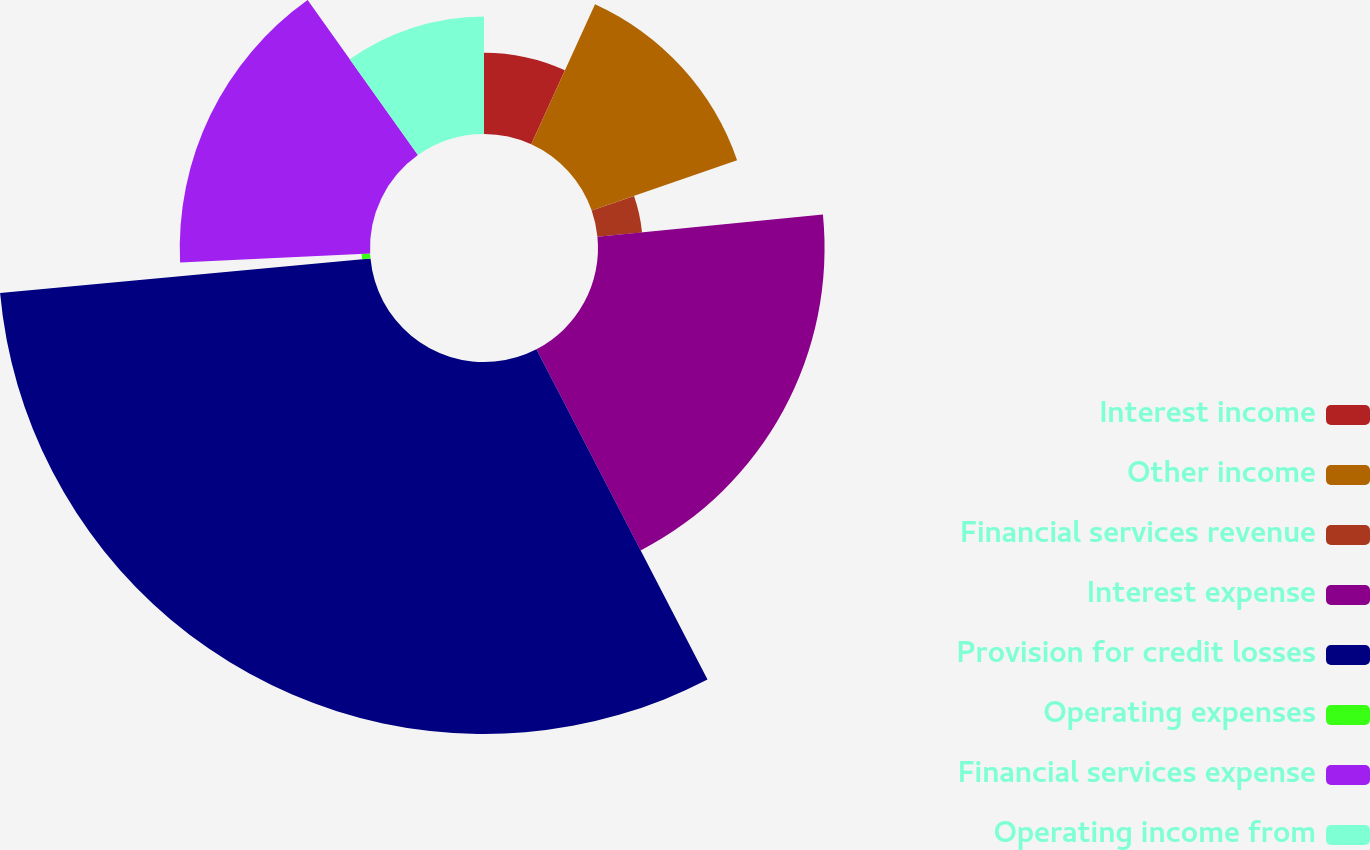Convert chart to OTSL. <chart><loc_0><loc_0><loc_500><loc_500><pie_chart><fcel>Interest income<fcel>Other income<fcel>Financial services revenue<fcel>Interest expense<fcel>Provision for credit losses<fcel>Operating expenses<fcel>Financial services expense<fcel>Operating income from<nl><fcel>6.8%<fcel>12.88%<fcel>3.75%<fcel>18.96%<fcel>31.13%<fcel>0.71%<fcel>15.92%<fcel>9.84%<nl></chart> 